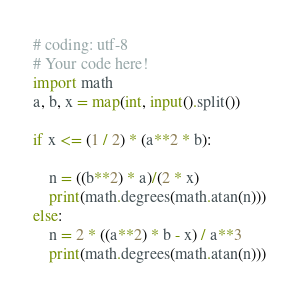Convert code to text. <code><loc_0><loc_0><loc_500><loc_500><_Python_># coding: utf-8
# Your code here!
import math
a, b, x = map(int, input().split())

if x <= (1 / 2) * (a**2 * b):
    
    n = ((b**2) * a)/(2 * x)
    print(math.degrees(math.atan(n)))
else:
    n = 2 * ((a**2) * b - x) / a**3
    print(math.degrees(math.atan(n)))</code> 